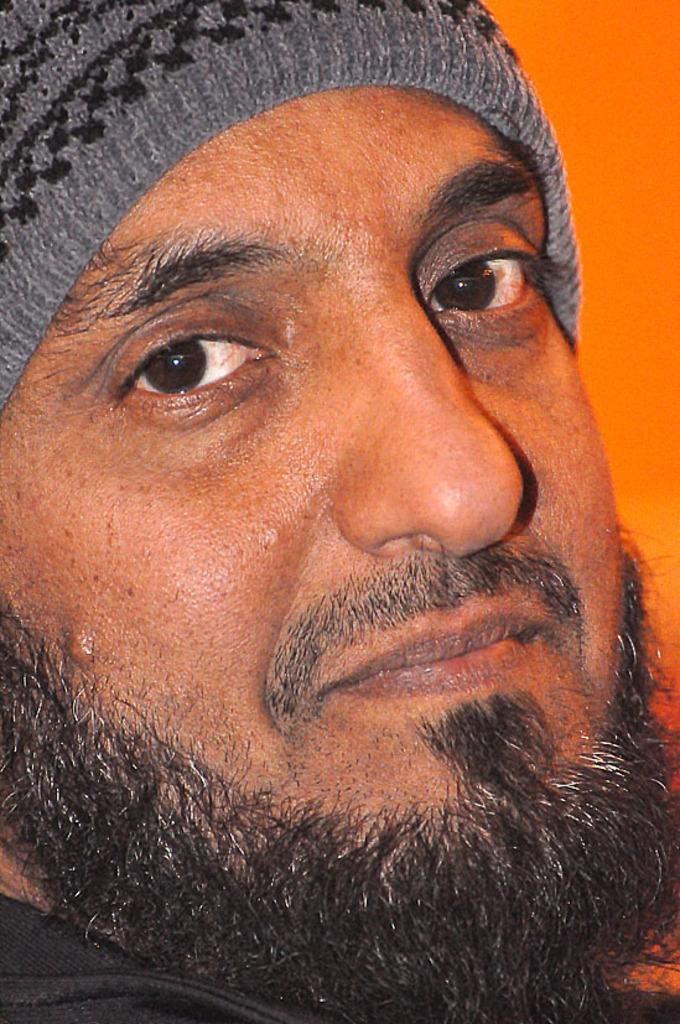Who is in the image? There is a man in the image. What is the man wearing on his upper body? The man is wearing a black jacket. What type of headwear is the man wearing? The man is wearing a grey cap. What is the man doing in the image? The man is looking at the camera and smiling. What color is the background of the image? The background of the image is orange in color. What type of hammer is the man holding in the image? There is no hammer present in the image; the man is only wearing a black jacket and a grey cap, and he is looking at the camera and smiling. 